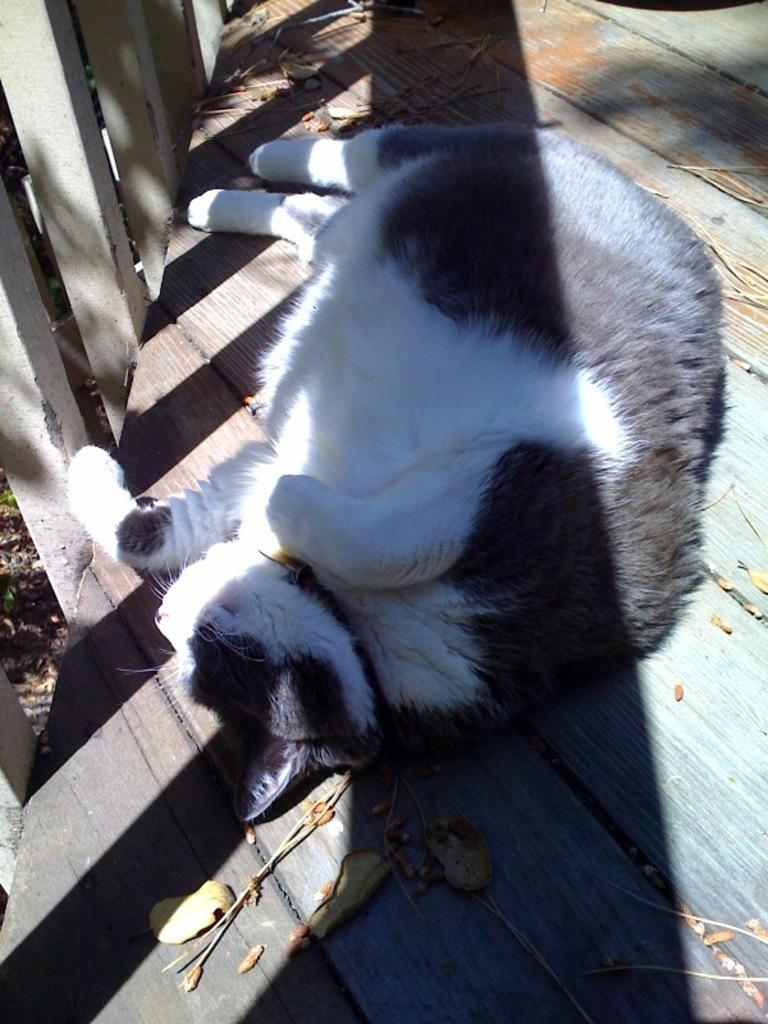What is the main subject in the foreground of the image? There is a cat in the foreground of the image. What is the cat doing in the image? The cat is sleeping. What can be seen falling down on the surface in the image? There are dried leaves falling down on the surface. Where is the railing located in the image? The railing is in the left top corner of the image. What type of representative is standing next to the cat in the image? There is no representative present in the image; it only features a cat sleeping and falling dried leaves. Can you tell me how many horses are visible in the image? There are no horses present in the image. 